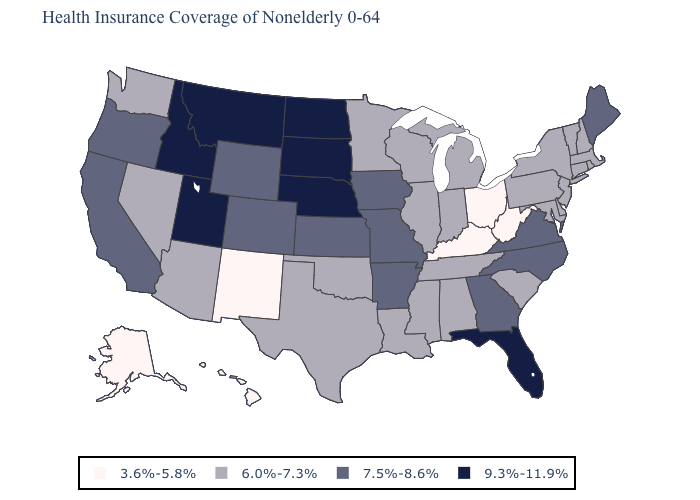Among the states that border Oregon , which have the lowest value?
Short answer required. Nevada, Washington. Does the first symbol in the legend represent the smallest category?
Short answer required. Yes. How many symbols are there in the legend?
Concise answer only. 4. Does Illinois have the highest value in the USA?
Quick response, please. No. What is the lowest value in the MidWest?
Quick response, please. 3.6%-5.8%. Which states have the lowest value in the USA?
Concise answer only. Alaska, Hawaii, Kentucky, New Mexico, Ohio, West Virginia. Does the map have missing data?
Be succinct. No. Name the states that have a value in the range 9.3%-11.9%?
Answer briefly. Florida, Idaho, Montana, Nebraska, North Dakota, South Dakota, Utah. Name the states that have a value in the range 6.0%-7.3%?
Keep it brief. Alabama, Arizona, Connecticut, Delaware, Illinois, Indiana, Louisiana, Maryland, Massachusetts, Michigan, Minnesota, Mississippi, Nevada, New Hampshire, New Jersey, New York, Oklahoma, Pennsylvania, Rhode Island, South Carolina, Tennessee, Texas, Vermont, Washington, Wisconsin. What is the lowest value in the West?
Quick response, please. 3.6%-5.8%. Name the states that have a value in the range 6.0%-7.3%?
Short answer required. Alabama, Arizona, Connecticut, Delaware, Illinois, Indiana, Louisiana, Maryland, Massachusetts, Michigan, Minnesota, Mississippi, Nevada, New Hampshire, New Jersey, New York, Oklahoma, Pennsylvania, Rhode Island, South Carolina, Tennessee, Texas, Vermont, Washington, Wisconsin. What is the highest value in the South ?
Be succinct. 9.3%-11.9%. What is the value of Oklahoma?
Answer briefly. 6.0%-7.3%. Name the states that have a value in the range 3.6%-5.8%?
Quick response, please. Alaska, Hawaii, Kentucky, New Mexico, Ohio, West Virginia. 